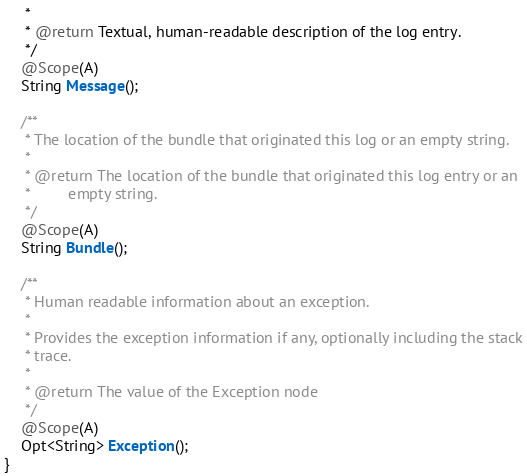<code> <loc_0><loc_0><loc_500><loc_500><_Java_>	 * 
	 * @return Textual, human-readable description of the log entry.
	 */
	@Scope(A)
	String Message();

	/**
	 * The location of the bundle that originated this log or an empty string.
	 * 
	 * @return The location of the bundle that originated this log entry or an
	 *         empty string.
	 */
	@Scope(A)
	String Bundle();

	/**
	 * Human readable information about an exception.
	 * 
	 * Provides the exception information if any, optionally including the stack
	 * trace.
	 * 
	 * @return The value of the Exception node
	 */
	@Scope(A)
	Opt<String> Exception();
}
</code> 